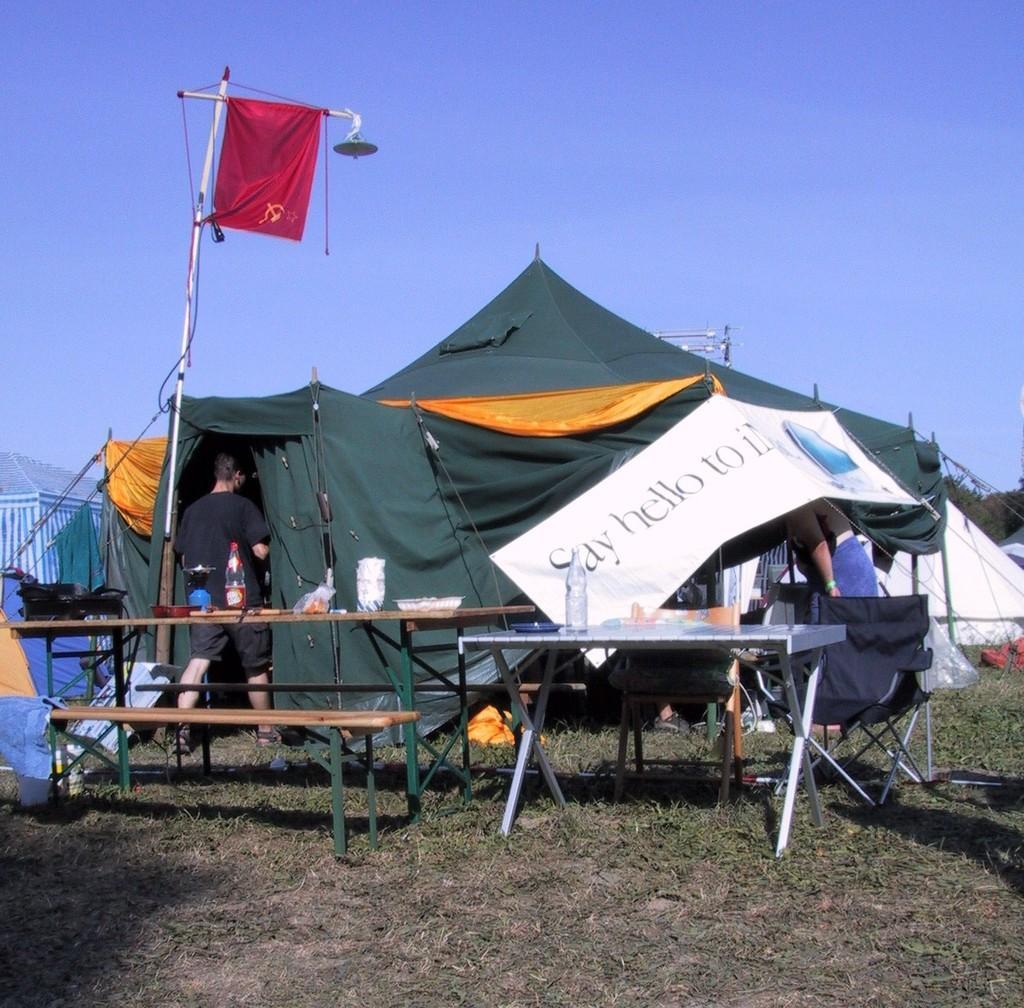Describe this image in one or two sentences. At the top there is a clear blue sky. Here we can see tents. This is a banner. Here we can see two people. Here we can see a bench and on the tables we can see bottles and other objects. This is a chair. Here we can see grass. 